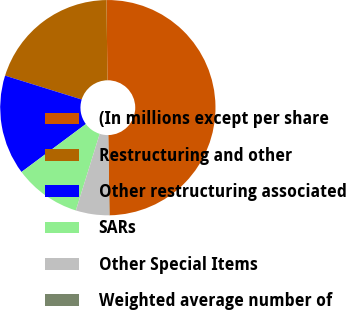<chart> <loc_0><loc_0><loc_500><loc_500><pie_chart><fcel>(In millions except per share<fcel>Restructuring and other<fcel>Other restructuring associated<fcel>SARs<fcel>Other Special Items<fcel>Weighted average number of<nl><fcel>49.95%<fcel>19.99%<fcel>15.0%<fcel>10.01%<fcel>5.02%<fcel>0.03%<nl></chart> 